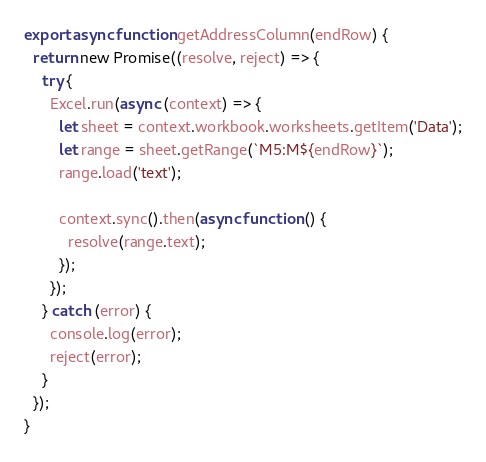Convert code to text. <code><loc_0><loc_0><loc_500><loc_500><_JavaScript_>export async function getAddressColumn(endRow) {
  return new Promise((resolve, reject) => {
    try {
      Excel.run(async (context) => {
        let sheet = context.workbook.worksheets.getItem('Data');
        let range = sheet.getRange(`M5:M${endRow}`);
        range.load('text');

        context.sync().then(async function () {
          resolve(range.text);
        });
      });
    } catch (error) {
      console.log(error);
      reject(error);
    }
  });
}
</code> 